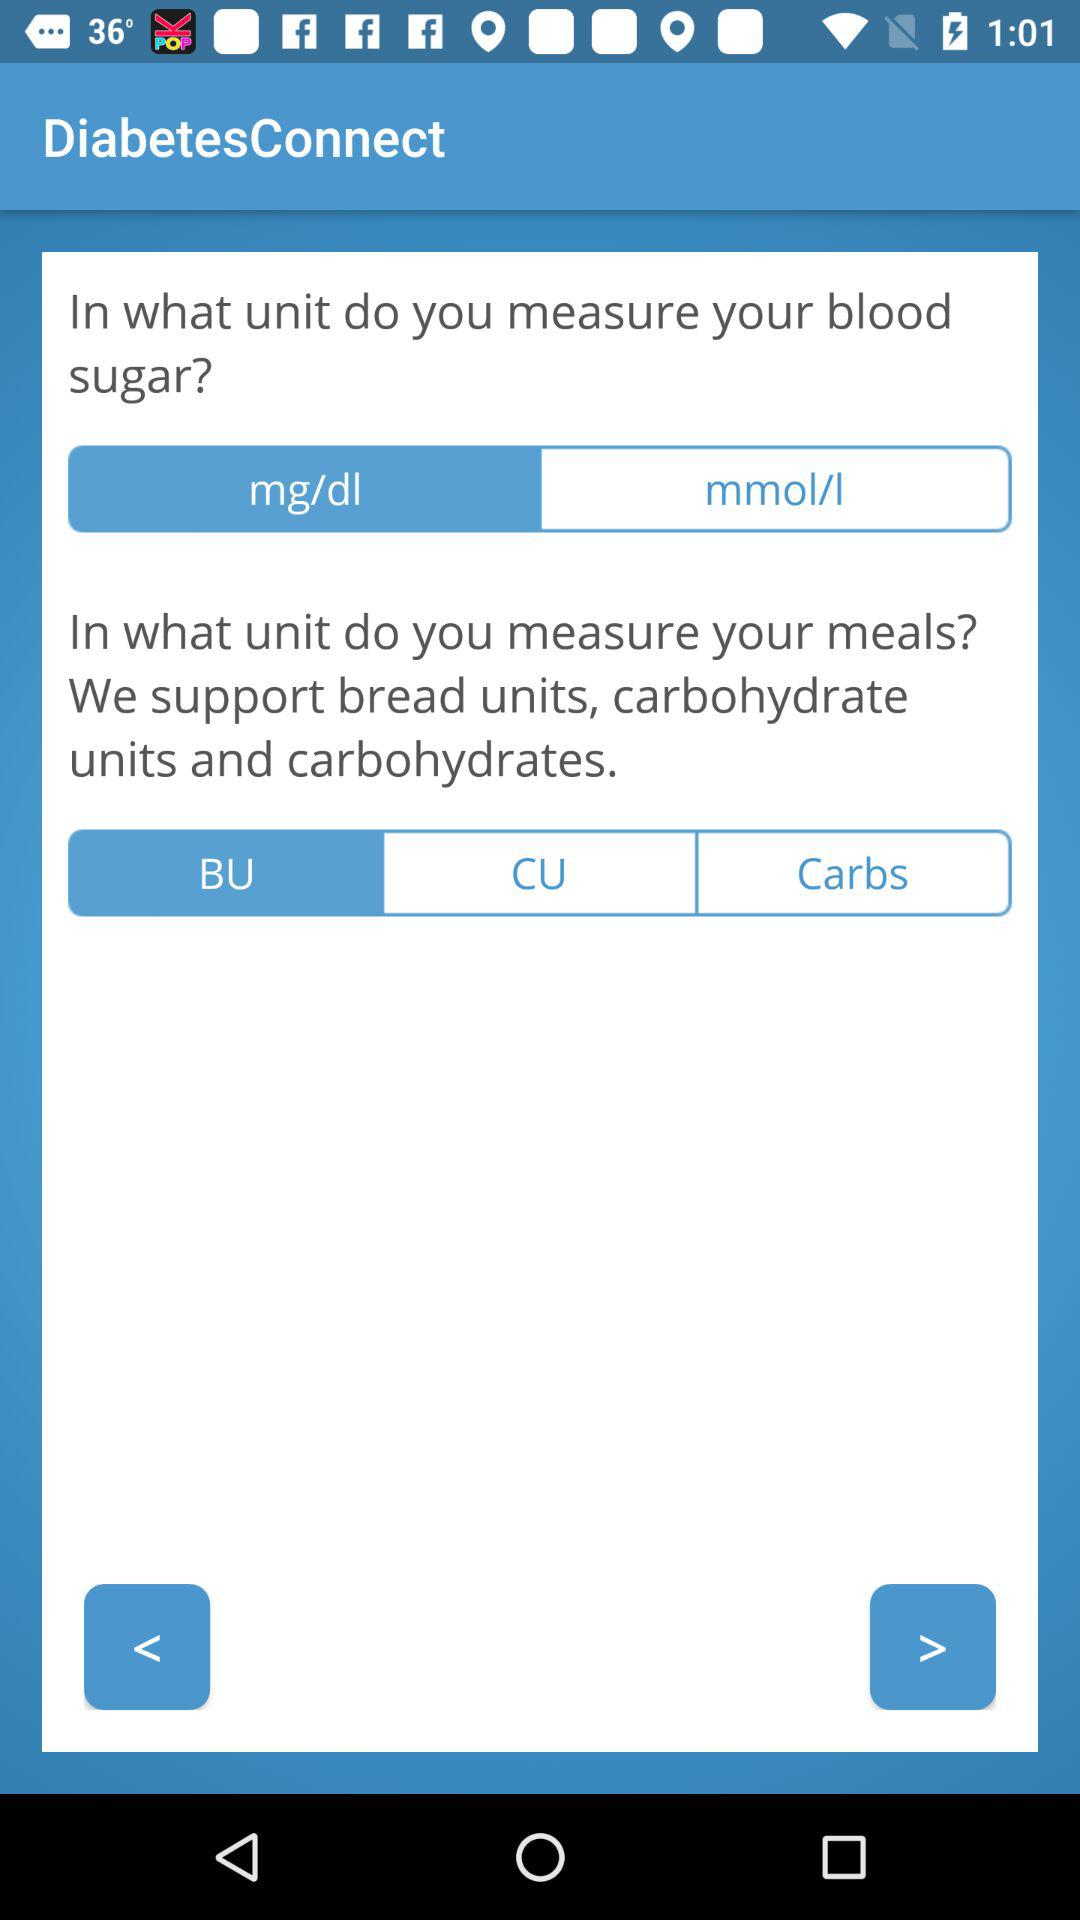What is the unit of measuring blood sugar? The unit is mg/dl. 